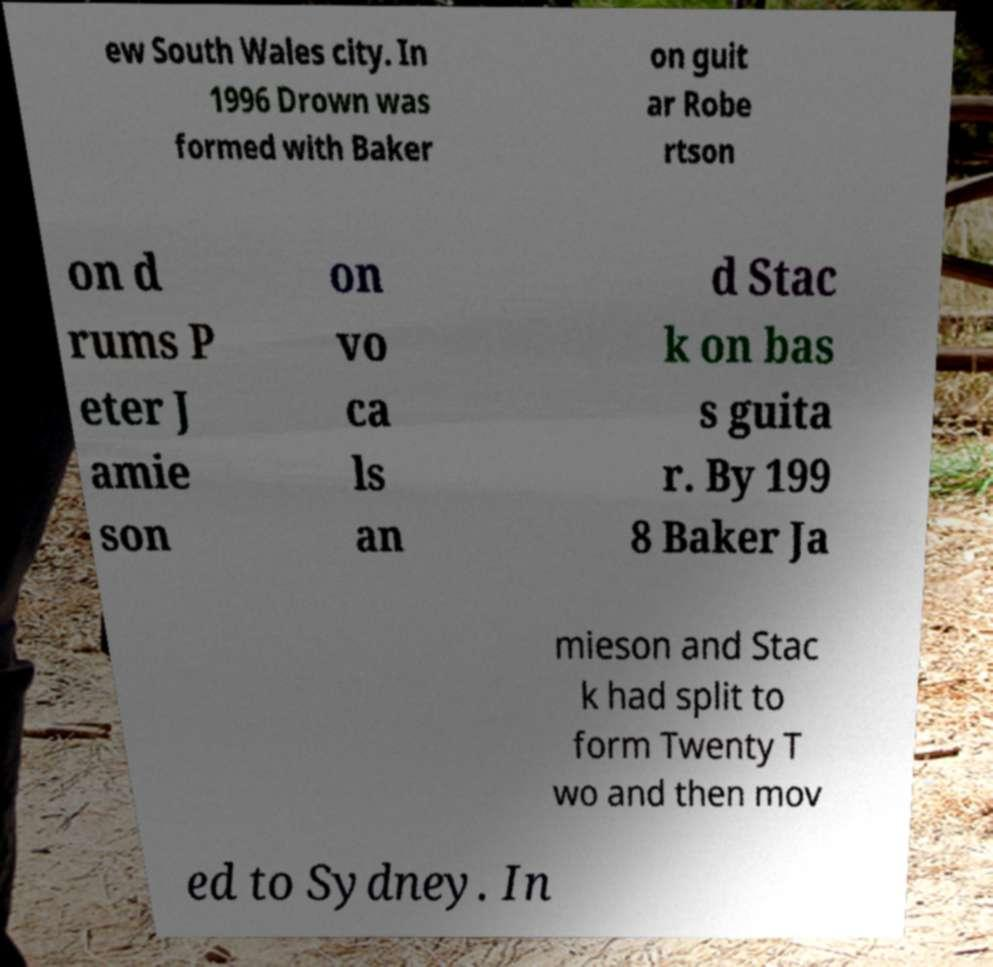Please identify and transcribe the text found in this image. ew South Wales city. In 1996 Drown was formed with Baker on guit ar Robe rtson on d rums P eter J amie son on vo ca ls an d Stac k on bas s guita r. By 199 8 Baker Ja mieson and Stac k had split to form Twenty T wo and then mov ed to Sydney. In 